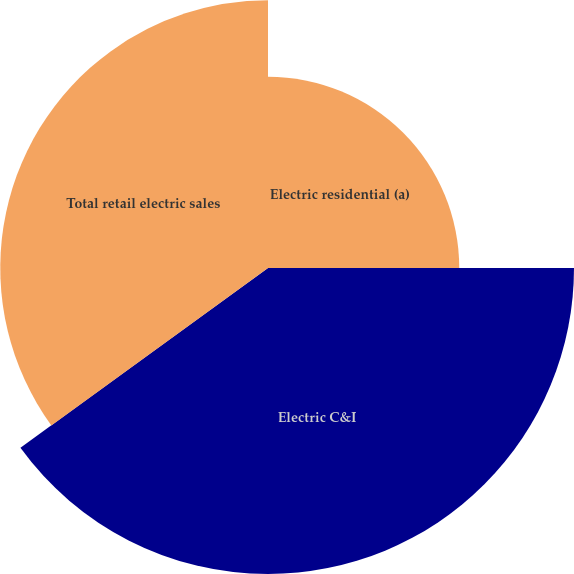<chart> <loc_0><loc_0><loc_500><loc_500><pie_chart><fcel>Electric residential (a)<fcel>Electric C&I<fcel>Total retail electric sales<nl><fcel>25.0%<fcel>40.0%<fcel>35.0%<nl></chart> 